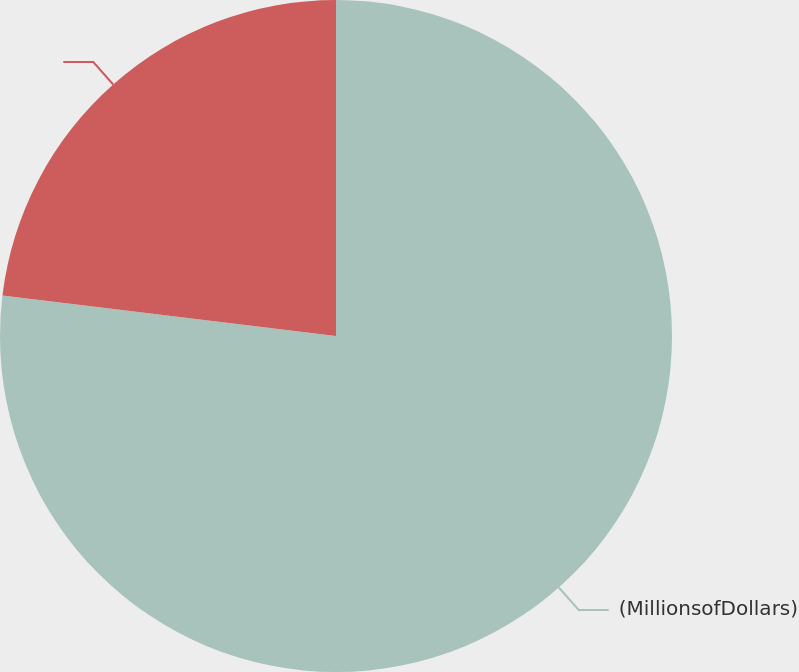Convert chart. <chart><loc_0><loc_0><loc_500><loc_500><pie_chart><fcel>(MillionsofDollars)<fcel>Unnamed: 1<nl><fcel>76.92%<fcel>23.08%<nl></chart> 